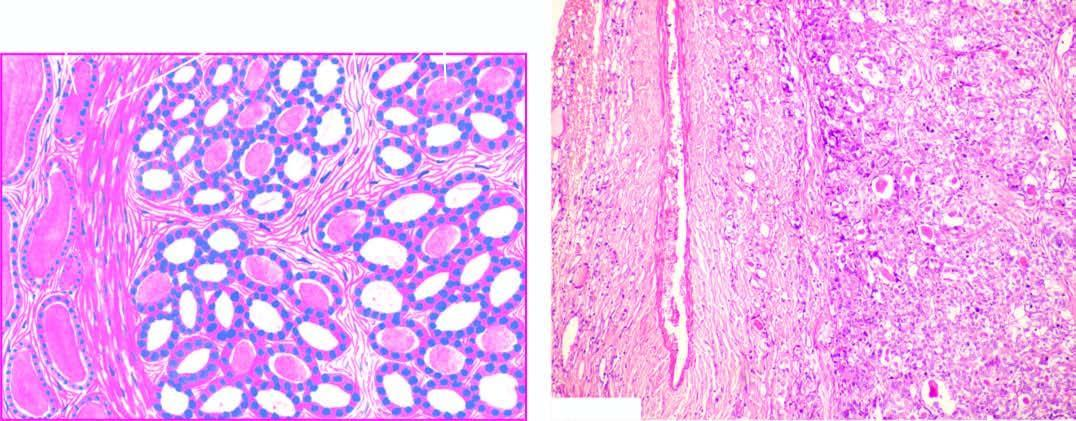does the tumour consist of small follicles lined by cuboidal epithelium and contain little or no colloid and separated by abundant loose stroma?
Answer the question using a single word or phrase. Yes 